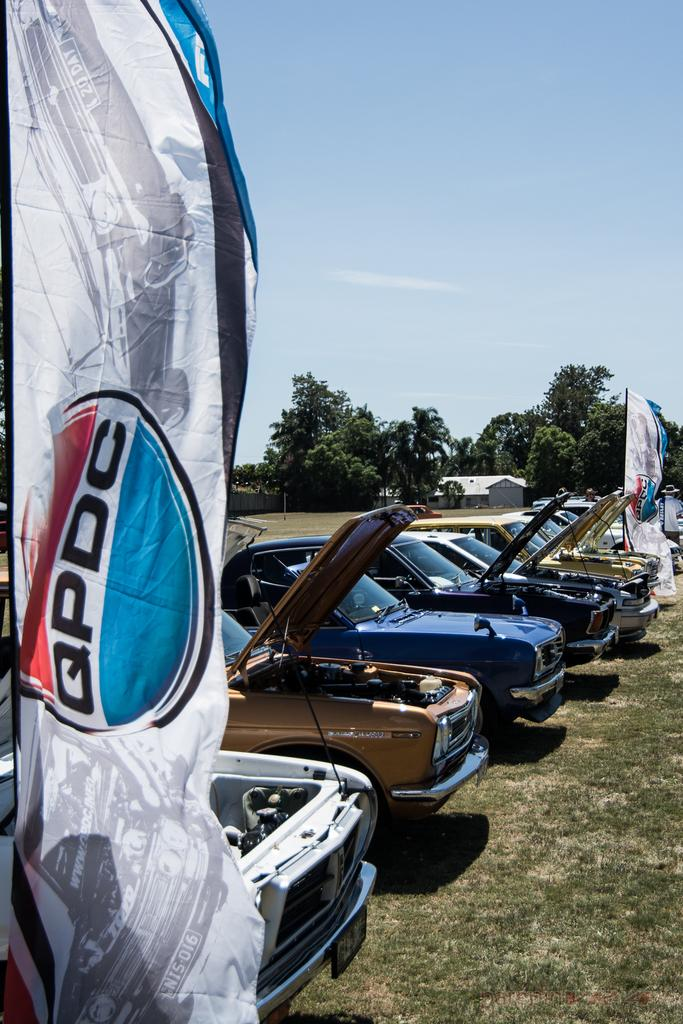What is written on the banners in the image? The facts do not specify the text on the banners, so we cannot answer this question definitively. What is the condition of the cars in the image? The cars in the image have open bonnets. What can be seen in the background of the image? There is a building, trees, and the sky visible in the background of the image. Where is the dock located in the image? There is no dock present in the image. What type of school is depicted in the image? There is no school present in the image. 